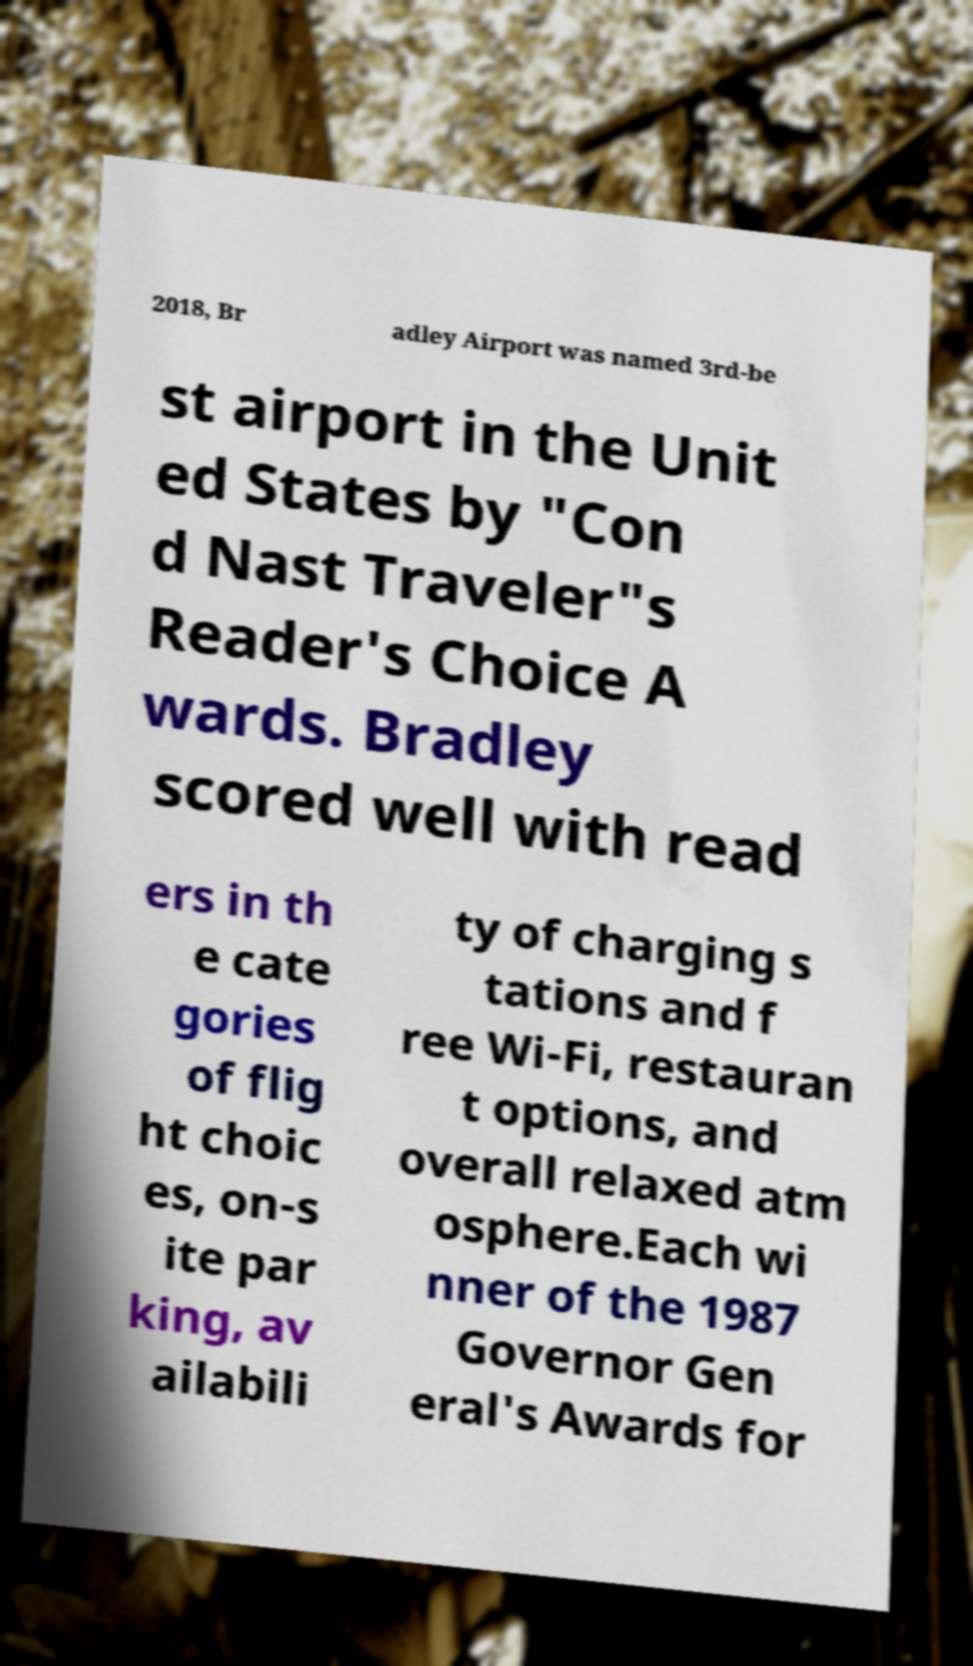For documentation purposes, I need the text within this image transcribed. Could you provide that? 2018, Br adley Airport was named 3rd-be st airport in the Unit ed States by "Con d Nast Traveler"s Reader's Choice A wards. Bradley scored well with read ers in th e cate gories of flig ht choic es, on-s ite par king, av ailabili ty of charging s tations and f ree Wi-Fi, restauran t options, and overall relaxed atm osphere.Each wi nner of the 1987 Governor Gen eral's Awards for 